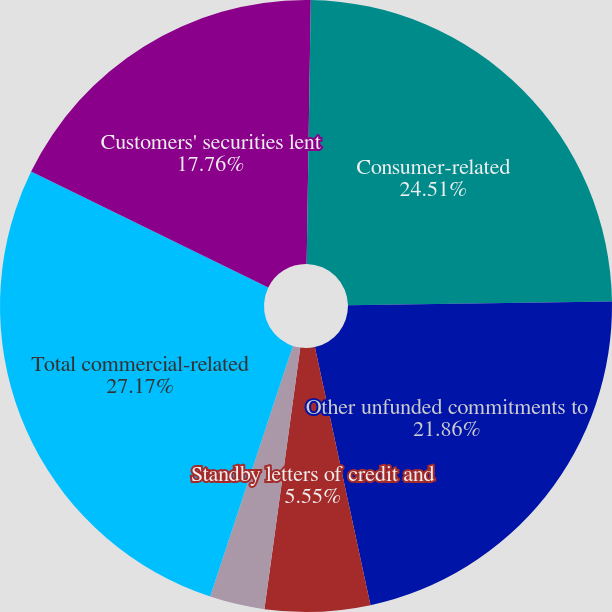Convert chart to OTSL. <chart><loc_0><loc_0><loc_500><loc_500><pie_chart><fcel>December 31 (in millions)<fcel>Consumer-related<fcel>Other unfunded commitments to<fcel>Standby letters of credit and<fcel>Other letters of credit (a)<fcel>Total commercial-related<fcel>Customers' securities lent<nl><fcel>0.25%<fcel>24.51%<fcel>21.86%<fcel>5.55%<fcel>2.9%<fcel>27.17%<fcel>17.76%<nl></chart> 